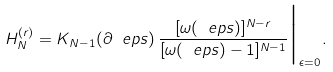Convert formula to latex. <formula><loc_0><loc_0><loc_500><loc_500>H _ { N } ^ { ( r ) } = K _ { N - 1 } ( \partial _ { \ } e p s ) \, \frac { [ \omega ( \ e p s ) ] ^ { N - r } } { [ \omega ( \ e p s ) - 1 ] ^ { N - 1 } } \Big | _ { \epsilon = 0 } .</formula> 